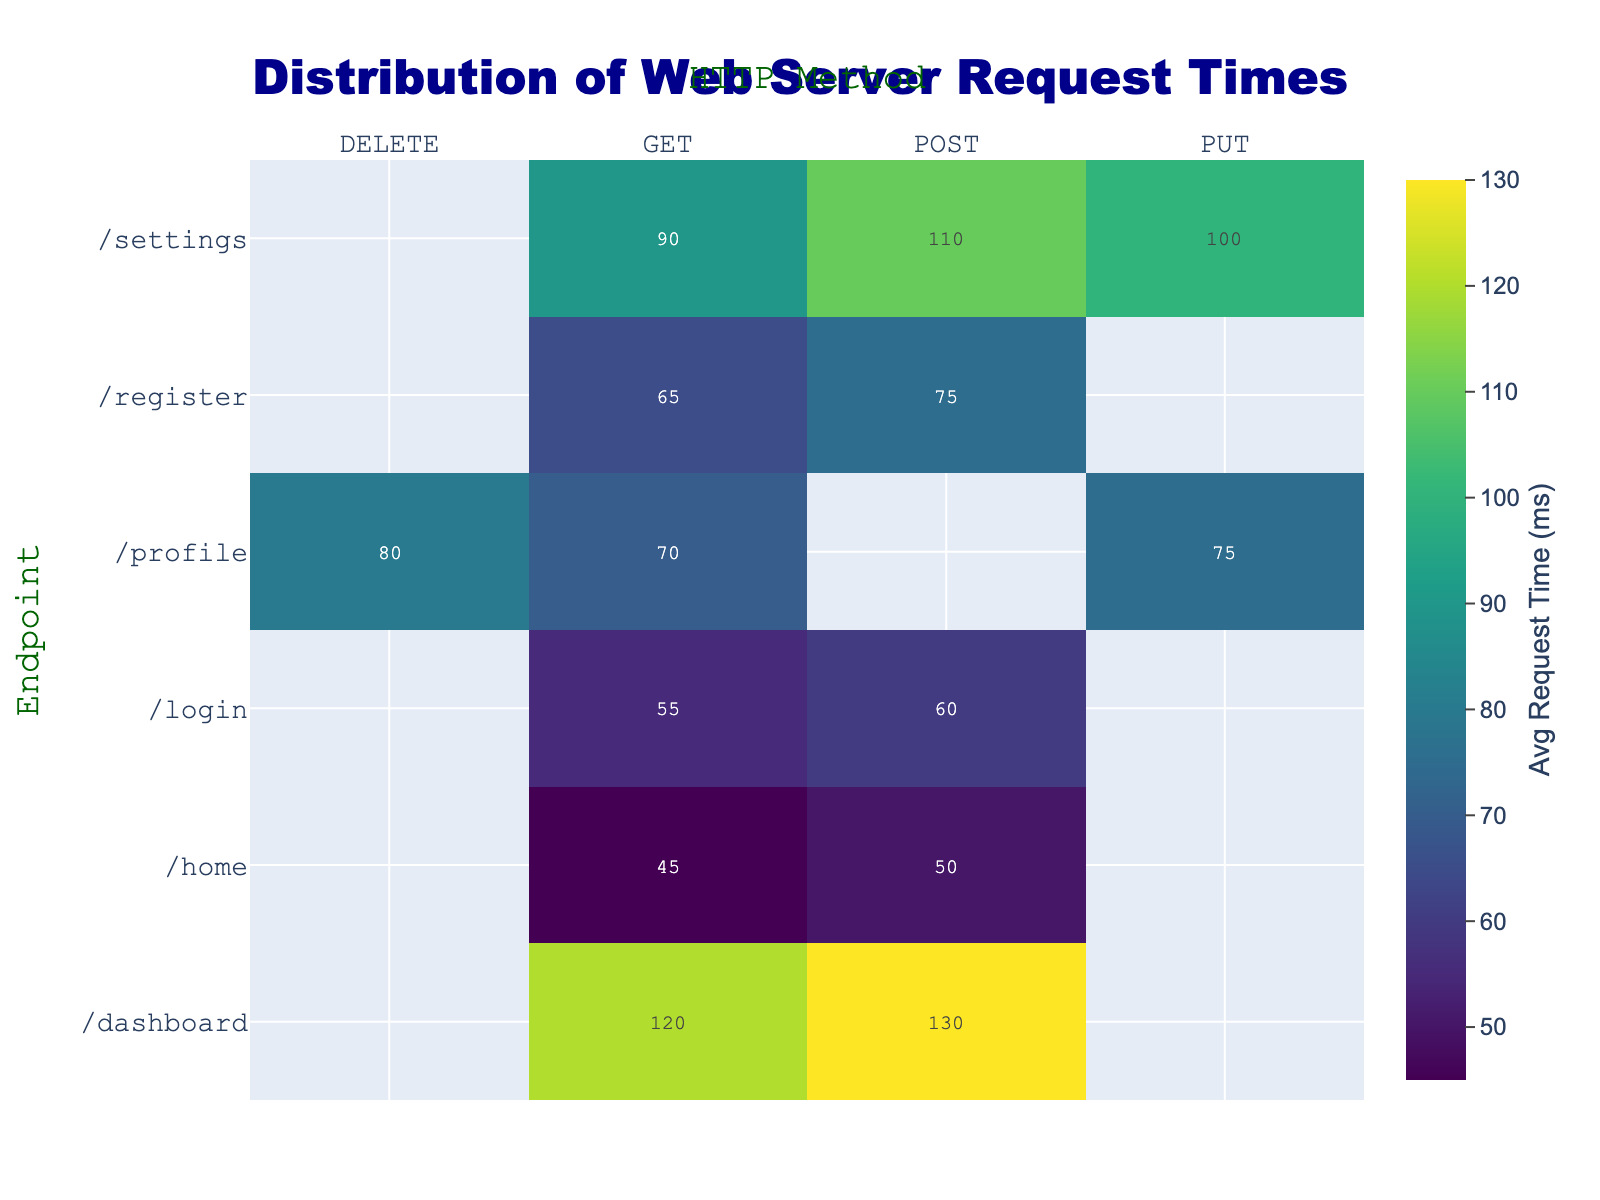what is the title of the heatmap? The title is located at the top of the figure in a large font. It indicates the overall subject of the heatmap, which is "Distribution of Web Server Request Times".
Answer: Distribution of Web Server Request Times Which endpoint has the highest average request time? To determine this, look at the heatmap and identify the cell with the highest value. The endpoint associated with this cell will have the highest average request time.
Answer: /dashboard What is the difference in average request time between GET and POST methods for the /home endpoint? Locate the values for the GET and POST methods under the /home endpoint and subtract the GET value from the POST value (50 - 45 = 5).
Answer: 5 ms Which HTTP method generally takes longer for the /settings endpoint, GET or PUT? Compare the average request times for the GET and PUT methods under the /settings endpoint. The method with the larger value takes longer.
Answer: PUT Are there any endpoints where all HTTP methods have the exact same average request time? Check each endpoint to see if all the cells (values) corresponding to different HTTP methods are identical.
Answer: No What is the average request time for all methods combined for the /profile endpoint? Add the average request times for all methods under the /profile endpoint and divide by the number of methods ([70 + 75 + 80] / 3).
Answer: 75 ms Which endpoint has the lowest average request time and what HTTP method is it? Find the cell with the smallest value on the heatmap and identify the corresponding endpoint and HTTP method.
Answer: /home, GET Compare the average request times for the GET method across all endpoints. Which endpoint has the longest time? Look at the values for the GET method across all endpoints and find the largest value. The endpoint associated with this value has the longest time.
Answer: /dashboard What is the total average request time for the POST method for all endpoints? Add the average request times for the POST method across all endpoints. Summation: 50 + 130 + 60 + 75 + 110 = 425 ms
Answer: 425 ms 